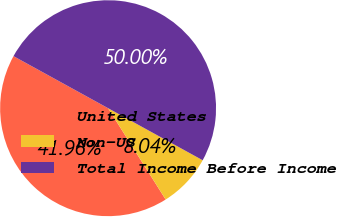Convert chart. <chart><loc_0><loc_0><loc_500><loc_500><pie_chart><fcel>United States<fcel>Non-US<fcel>Total Income Before Income<nl><fcel>41.96%<fcel>8.04%<fcel>50.0%<nl></chart> 